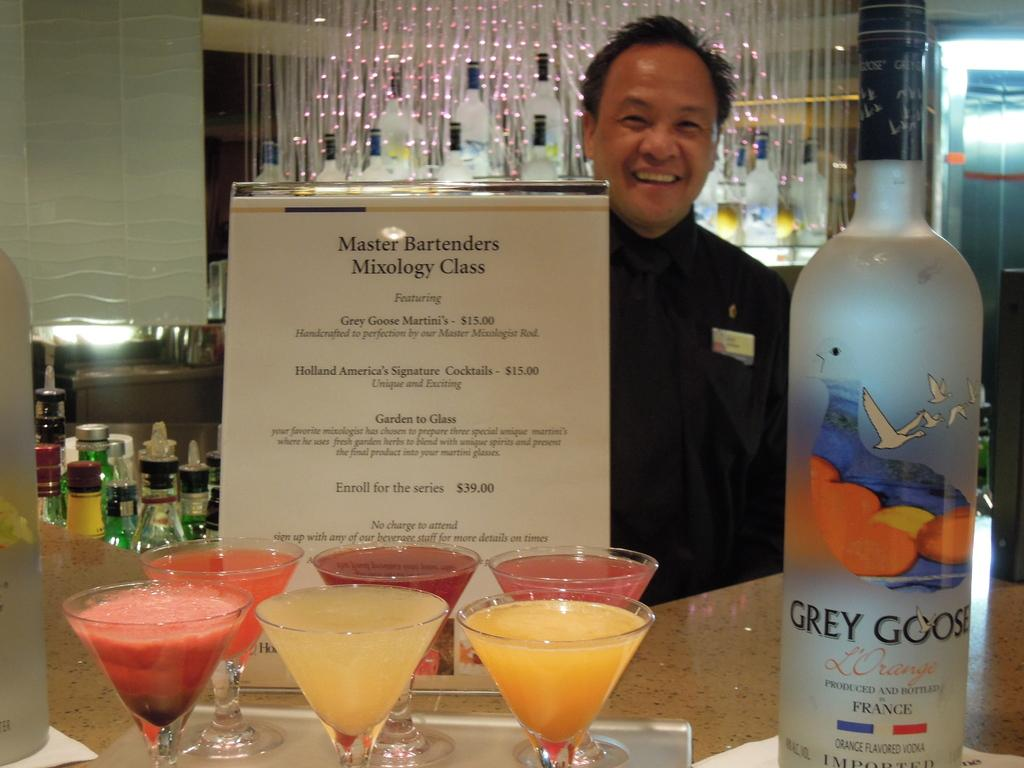<image>
Render a clear and concise summary of the photo. Bar scene with an advertisement for Master Bartender Mixology class and bottle of Grey Goose 